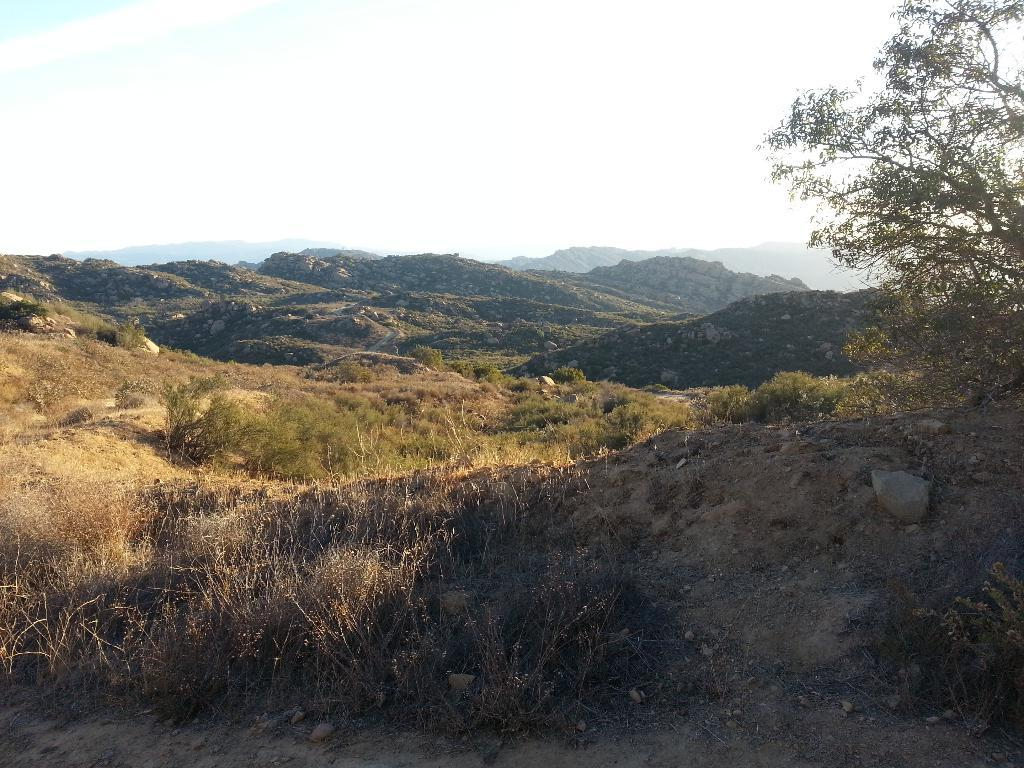What type of vegetation can be seen in the image? There are plants and a tree visible in the image. What type of landscape feature is visible in the image? There are hills visible in the image. What part of the natural environment is visible in the image? The sky is visible in the image. How many people are swimming in the image? There are no people visible in the image, let alone swimming. 